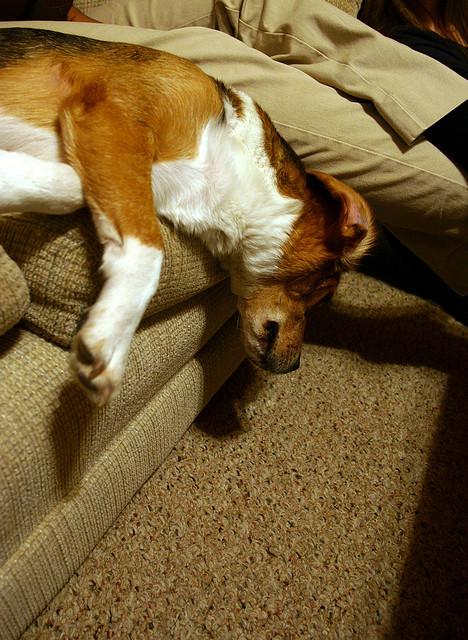What is the dog sleeping on?
Concise answer only. Couch. Where is the dog sleeping?
Concise answer only. Couch. Is this a good dog?
Be succinct. Yes. What color is the carpet?
Be succinct. Brown. Is the dog playing?
Quick response, please. No. Does the dog look like he's sleeping?
Be succinct. Yes. Where is the dog lying?
Concise answer only. Couch. 